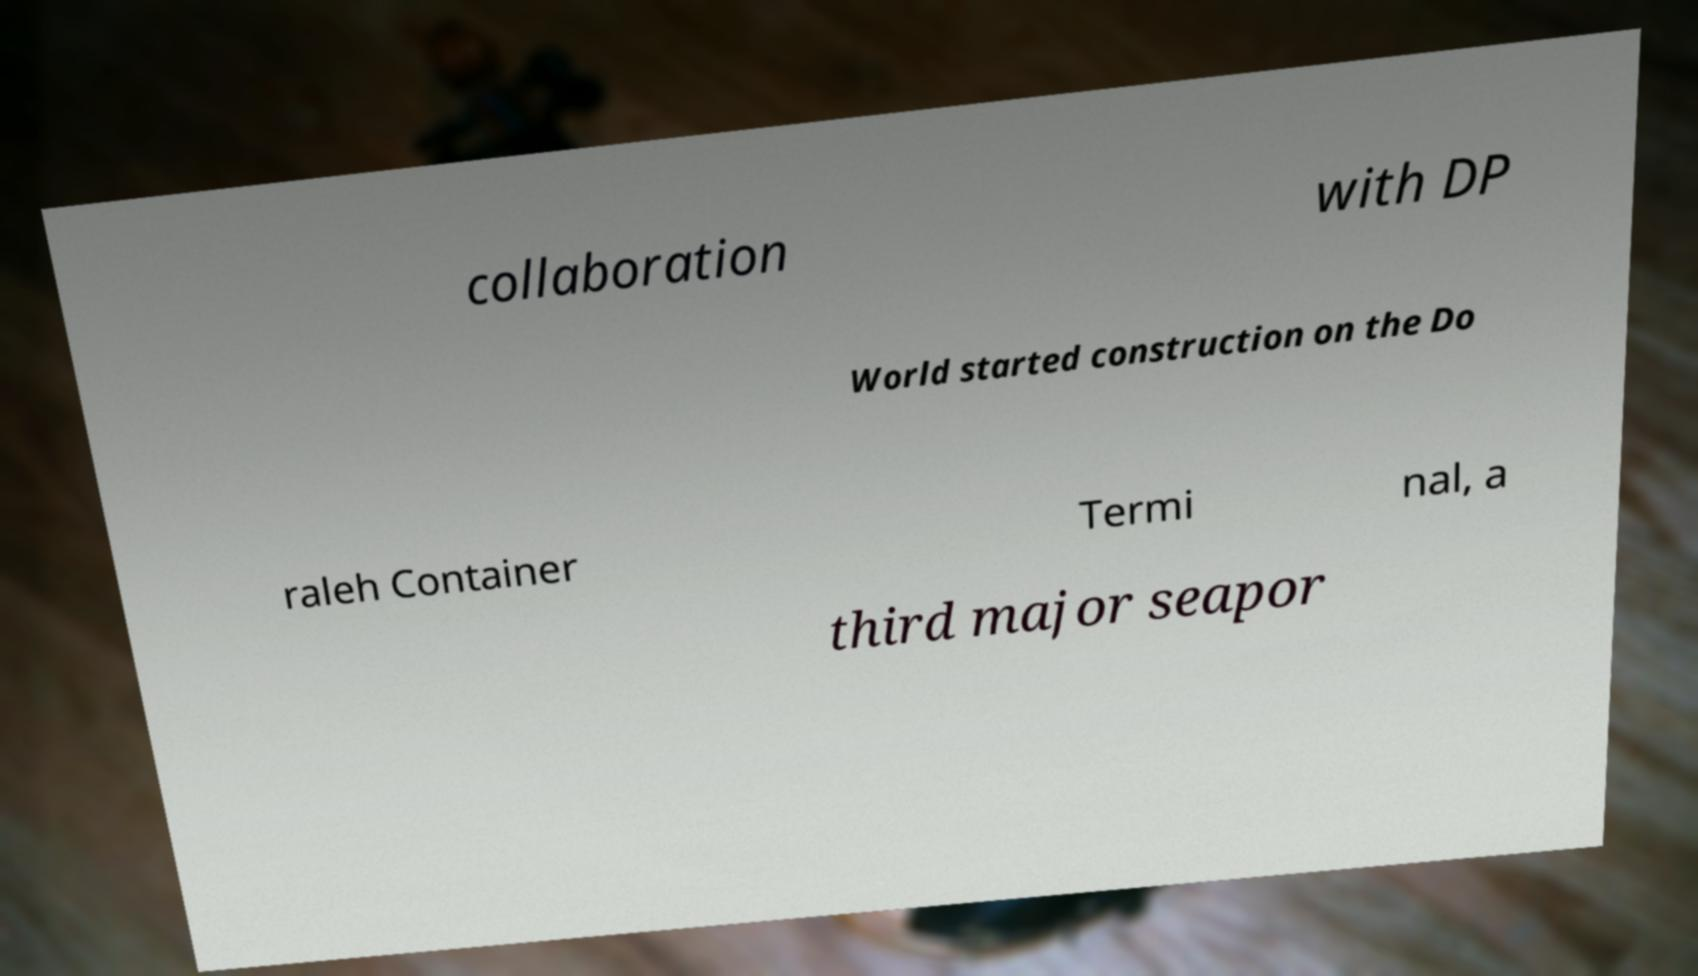What messages or text are displayed in this image? I need them in a readable, typed format. collaboration with DP World started construction on the Do raleh Container Termi nal, a third major seapor 